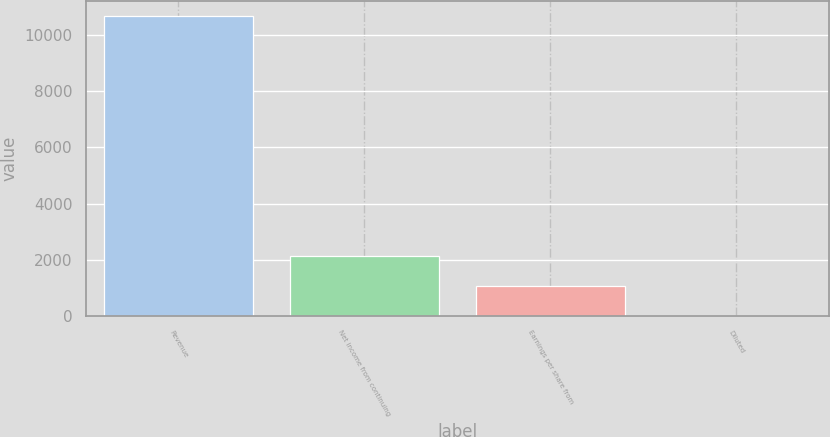Convert chart. <chart><loc_0><loc_0><loc_500><loc_500><bar_chart><fcel>Revenue<fcel>Net income from continuing<fcel>Earnings per share from<fcel>Diluted<nl><fcel>10669<fcel>2135.53<fcel>1068.84<fcel>2.15<nl></chart> 